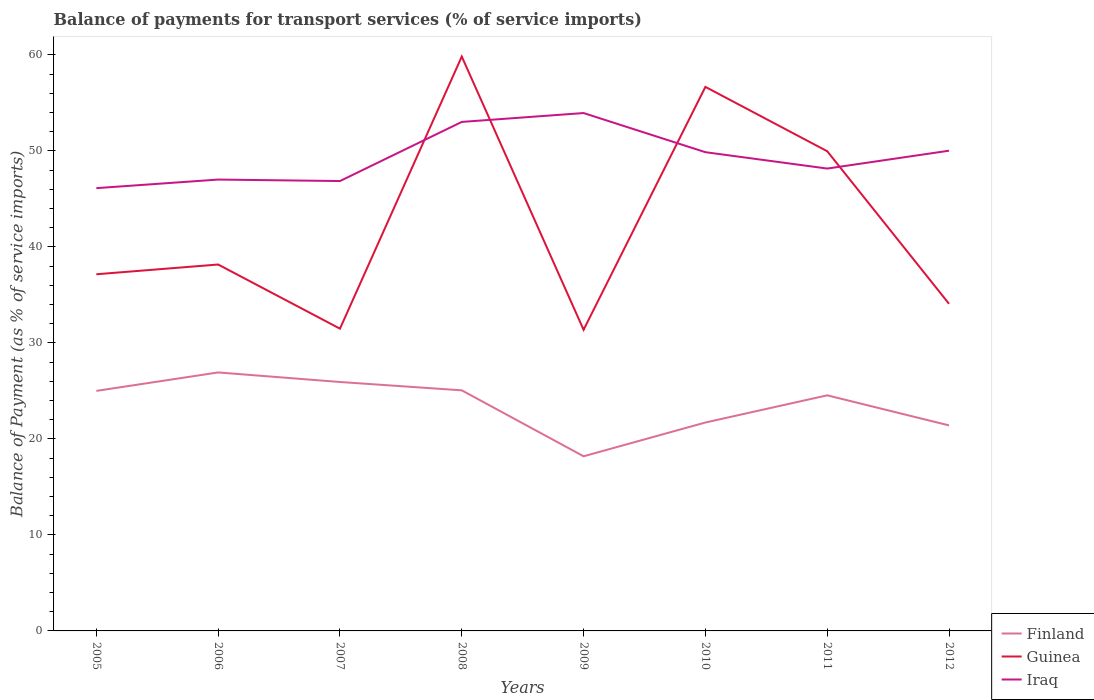How many different coloured lines are there?
Give a very brief answer. 3. Across all years, what is the maximum balance of payments for transport services in Iraq?
Keep it short and to the point. 46.13. In which year was the balance of payments for transport services in Iraq maximum?
Provide a short and direct response. 2005. What is the total balance of payments for transport services in Iraq in the graph?
Provide a succinct answer. -7.08. What is the difference between the highest and the second highest balance of payments for transport services in Finland?
Keep it short and to the point. 8.73. What is the difference between the highest and the lowest balance of payments for transport services in Guinea?
Ensure brevity in your answer.  3. How many lines are there?
Your answer should be compact. 3. Are the values on the major ticks of Y-axis written in scientific E-notation?
Give a very brief answer. No. Does the graph contain any zero values?
Your answer should be very brief. No. Does the graph contain grids?
Your answer should be compact. No. Where does the legend appear in the graph?
Offer a terse response. Bottom right. What is the title of the graph?
Your answer should be compact. Balance of payments for transport services (% of service imports). What is the label or title of the Y-axis?
Provide a succinct answer. Balance of Payment (as % of service imports). What is the Balance of Payment (as % of service imports) in Finland in 2005?
Keep it short and to the point. 25. What is the Balance of Payment (as % of service imports) of Guinea in 2005?
Your answer should be compact. 37.16. What is the Balance of Payment (as % of service imports) of Iraq in 2005?
Keep it short and to the point. 46.13. What is the Balance of Payment (as % of service imports) of Finland in 2006?
Provide a short and direct response. 26.93. What is the Balance of Payment (as % of service imports) of Guinea in 2006?
Provide a succinct answer. 38.17. What is the Balance of Payment (as % of service imports) in Iraq in 2006?
Offer a very short reply. 47.02. What is the Balance of Payment (as % of service imports) of Finland in 2007?
Offer a very short reply. 25.93. What is the Balance of Payment (as % of service imports) of Guinea in 2007?
Make the answer very short. 31.49. What is the Balance of Payment (as % of service imports) of Iraq in 2007?
Provide a short and direct response. 46.87. What is the Balance of Payment (as % of service imports) in Finland in 2008?
Offer a very short reply. 25.06. What is the Balance of Payment (as % of service imports) of Guinea in 2008?
Offer a terse response. 59.83. What is the Balance of Payment (as % of service imports) in Iraq in 2008?
Your response must be concise. 53.03. What is the Balance of Payment (as % of service imports) in Finland in 2009?
Give a very brief answer. 18.19. What is the Balance of Payment (as % of service imports) of Guinea in 2009?
Your answer should be compact. 31.37. What is the Balance of Payment (as % of service imports) of Iraq in 2009?
Your response must be concise. 53.95. What is the Balance of Payment (as % of service imports) of Finland in 2010?
Provide a short and direct response. 21.71. What is the Balance of Payment (as % of service imports) of Guinea in 2010?
Offer a very short reply. 56.67. What is the Balance of Payment (as % of service imports) in Iraq in 2010?
Your response must be concise. 49.87. What is the Balance of Payment (as % of service imports) of Finland in 2011?
Give a very brief answer. 24.54. What is the Balance of Payment (as % of service imports) of Guinea in 2011?
Give a very brief answer. 49.97. What is the Balance of Payment (as % of service imports) of Iraq in 2011?
Your response must be concise. 48.17. What is the Balance of Payment (as % of service imports) of Finland in 2012?
Provide a short and direct response. 21.41. What is the Balance of Payment (as % of service imports) in Guinea in 2012?
Offer a terse response. 34.08. What is the Balance of Payment (as % of service imports) of Iraq in 2012?
Your response must be concise. 50.03. Across all years, what is the maximum Balance of Payment (as % of service imports) in Finland?
Give a very brief answer. 26.93. Across all years, what is the maximum Balance of Payment (as % of service imports) in Guinea?
Your answer should be very brief. 59.83. Across all years, what is the maximum Balance of Payment (as % of service imports) of Iraq?
Provide a short and direct response. 53.95. Across all years, what is the minimum Balance of Payment (as % of service imports) in Finland?
Offer a terse response. 18.19. Across all years, what is the minimum Balance of Payment (as % of service imports) of Guinea?
Provide a succinct answer. 31.37. Across all years, what is the minimum Balance of Payment (as % of service imports) of Iraq?
Your answer should be compact. 46.13. What is the total Balance of Payment (as % of service imports) in Finland in the graph?
Your answer should be very brief. 188.79. What is the total Balance of Payment (as % of service imports) in Guinea in the graph?
Keep it short and to the point. 338.74. What is the total Balance of Payment (as % of service imports) in Iraq in the graph?
Make the answer very short. 395.05. What is the difference between the Balance of Payment (as % of service imports) in Finland in 2005 and that in 2006?
Offer a terse response. -1.92. What is the difference between the Balance of Payment (as % of service imports) of Guinea in 2005 and that in 2006?
Make the answer very short. -1.01. What is the difference between the Balance of Payment (as % of service imports) of Iraq in 2005 and that in 2006?
Give a very brief answer. -0.89. What is the difference between the Balance of Payment (as % of service imports) in Finland in 2005 and that in 2007?
Ensure brevity in your answer.  -0.93. What is the difference between the Balance of Payment (as % of service imports) in Guinea in 2005 and that in 2007?
Keep it short and to the point. 5.67. What is the difference between the Balance of Payment (as % of service imports) of Iraq in 2005 and that in 2007?
Provide a succinct answer. -0.74. What is the difference between the Balance of Payment (as % of service imports) of Finland in 2005 and that in 2008?
Offer a very short reply. -0.06. What is the difference between the Balance of Payment (as % of service imports) in Guinea in 2005 and that in 2008?
Provide a short and direct response. -22.68. What is the difference between the Balance of Payment (as % of service imports) in Iraq in 2005 and that in 2008?
Provide a succinct answer. -6.9. What is the difference between the Balance of Payment (as % of service imports) in Finland in 2005 and that in 2009?
Offer a very short reply. 6.81. What is the difference between the Balance of Payment (as % of service imports) in Guinea in 2005 and that in 2009?
Your answer should be very brief. 5.78. What is the difference between the Balance of Payment (as % of service imports) in Iraq in 2005 and that in 2009?
Offer a very short reply. -7.82. What is the difference between the Balance of Payment (as % of service imports) of Finland in 2005 and that in 2010?
Provide a succinct answer. 3.29. What is the difference between the Balance of Payment (as % of service imports) in Guinea in 2005 and that in 2010?
Give a very brief answer. -19.52. What is the difference between the Balance of Payment (as % of service imports) in Iraq in 2005 and that in 2010?
Keep it short and to the point. -3.74. What is the difference between the Balance of Payment (as % of service imports) in Finland in 2005 and that in 2011?
Your answer should be compact. 0.46. What is the difference between the Balance of Payment (as % of service imports) of Guinea in 2005 and that in 2011?
Make the answer very short. -12.82. What is the difference between the Balance of Payment (as % of service imports) of Iraq in 2005 and that in 2011?
Offer a very short reply. -2.04. What is the difference between the Balance of Payment (as % of service imports) of Finland in 2005 and that in 2012?
Your response must be concise. 3.59. What is the difference between the Balance of Payment (as % of service imports) of Guinea in 2005 and that in 2012?
Give a very brief answer. 3.08. What is the difference between the Balance of Payment (as % of service imports) in Iraq in 2005 and that in 2012?
Your answer should be very brief. -3.9. What is the difference between the Balance of Payment (as % of service imports) in Guinea in 2006 and that in 2007?
Your response must be concise. 6.68. What is the difference between the Balance of Payment (as % of service imports) in Iraq in 2006 and that in 2007?
Give a very brief answer. 0.15. What is the difference between the Balance of Payment (as % of service imports) of Finland in 2006 and that in 2008?
Keep it short and to the point. 1.86. What is the difference between the Balance of Payment (as % of service imports) in Guinea in 2006 and that in 2008?
Offer a very short reply. -21.66. What is the difference between the Balance of Payment (as % of service imports) of Iraq in 2006 and that in 2008?
Make the answer very short. -6.01. What is the difference between the Balance of Payment (as % of service imports) in Finland in 2006 and that in 2009?
Keep it short and to the point. 8.73. What is the difference between the Balance of Payment (as % of service imports) of Guinea in 2006 and that in 2009?
Your answer should be very brief. 6.8. What is the difference between the Balance of Payment (as % of service imports) of Iraq in 2006 and that in 2009?
Your answer should be compact. -6.93. What is the difference between the Balance of Payment (as % of service imports) of Finland in 2006 and that in 2010?
Your answer should be compact. 5.22. What is the difference between the Balance of Payment (as % of service imports) in Guinea in 2006 and that in 2010?
Your answer should be very brief. -18.5. What is the difference between the Balance of Payment (as % of service imports) in Iraq in 2006 and that in 2010?
Make the answer very short. -2.85. What is the difference between the Balance of Payment (as % of service imports) of Finland in 2006 and that in 2011?
Provide a succinct answer. 2.38. What is the difference between the Balance of Payment (as % of service imports) in Guinea in 2006 and that in 2011?
Your response must be concise. -11.8. What is the difference between the Balance of Payment (as % of service imports) in Iraq in 2006 and that in 2011?
Offer a very short reply. -1.15. What is the difference between the Balance of Payment (as % of service imports) of Finland in 2006 and that in 2012?
Offer a terse response. 5.52. What is the difference between the Balance of Payment (as % of service imports) in Guinea in 2006 and that in 2012?
Make the answer very short. 4.09. What is the difference between the Balance of Payment (as % of service imports) in Iraq in 2006 and that in 2012?
Provide a succinct answer. -3.01. What is the difference between the Balance of Payment (as % of service imports) of Finland in 2007 and that in 2008?
Your answer should be very brief. 0.87. What is the difference between the Balance of Payment (as % of service imports) in Guinea in 2007 and that in 2008?
Offer a terse response. -28.35. What is the difference between the Balance of Payment (as % of service imports) of Iraq in 2007 and that in 2008?
Your response must be concise. -6.16. What is the difference between the Balance of Payment (as % of service imports) of Finland in 2007 and that in 2009?
Ensure brevity in your answer.  7.74. What is the difference between the Balance of Payment (as % of service imports) in Guinea in 2007 and that in 2009?
Keep it short and to the point. 0.12. What is the difference between the Balance of Payment (as % of service imports) of Iraq in 2007 and that in 2009?
Keep it short and to the point. -7.08. What is the difference between the Balance of Payment (as % of service imports) of Finland in 2007 and that in 2010?
Keep it short and to the point. 4.22. What is the difference between the Balance of Payment (as % of service imports) in Guinea in 2007 and that in 2010?
Make the answer very short. -25.19. What is the difference between the Balance of Payment (as % of service imports) of Iraq in 2007 and that in 2010?
Provide a succinct answer. -3.01. What is the difference between the Balance of Payment (as % of service imports) in Finland in 2007 and that in 2011?
Offer a very short reply. 1.39. What is the difference between the Balance of Payment (as % of service imports) of Guinea in 2007 and that in 2011?
Ensure brevity in your answer.  -18.48. What is the difference between the Balance of Payment (as % of service imports) in Iraq in 2007 and that in 2011?
Your response must be concise. -1.3. What is the difference between the Balance of Payment (as % of service imports) in Finland in 2007 and that in 2012?
Your answer should be compact. 4.52. What is the difference between the Balance of Payment (as % of service imports) in Guinea in 2007 and that in 2012?
Your response must be concise. -2.59. What is the difference between the Balance of Payment (as % of service imports) in Iraq in 2007 and that in 2012?
Your response must be concise. -3.16. What is the difference between the Balance of Payment (as % of service imports) in Finland in 2008 and that in 2009?
Your answer should be very brief. 6.87. What is the difference between the Balance of Payment (as % of service imports) of Guinea in 2008 and that in 2009?
Your answer should be compact. 28.46. What is the difference between the Balance of Payment (as % of service imports) of Iraq in 2008 and that in 2009?
Your response must be concise. -0.92. What is the difference between the Balance of Payment (as % of service imports) in Finland in 2008 and that in 2010?
Give a very brief answer. 3.35. What is the difference between the Balance of Payment (as % of service imports) of Guinea in 2008 and that in 2010?
Provide a succinct answer. 3.16. What is the difference between the Balance of Payment (as % of service imports) of Iraq in 2008 and that in 2010?
Make the answer very short. 3.15. What is the difference between the Balance of Payment (as % of service imports) of Finland in 2008 and that in 2011?
Your answer should be compact. 0.52. What is the difference between the Balance of Payment (as % of service imports) in Guinea in 2008 and that in 2011?
Your answer should be very brief. 9.86. What is the difference between the Balance of Payment (as % of service imports) in Iraq in 2008 and that in 2011?
Your response must be concise. 4.86. What is the difference between the Balance of Payment (as % of service imports) of Finland in 2008 and that in 2012?
Offer a very short reply. 3.65. What is the difference between the Balance of Payment (as % of service imports) in Guinea in 2008 and that in 2012?
Make the answer very short. 25.76. What is the difference between the Balance of Payment (as % of service imports) of Iraq in 2008 and that in 2012?
Keep it short and to the point. 3. What is the difference between the Balance of Payment (as % of service imports) in Finland in 2009 and that in 2010?
Your response must be concise. -3.52. What is the difference between the Balance of Payment (as % of service imports) in Guinea in 2009 and that in 2010?
Your answer should be very brief. -25.3. What is the difference between the Balance of Payment (as % of service imports) in Iraq in 2009 and that in 2010?
Offer a very short reply. 4.08. What is the difference between the Balance of Payment (as % of service imports) of Finland in 2009 and that in 2011?
Your answer should be very brief. -6.35. What is the difference between the Balance of Payment (as % of service imports) of Guinea in 2009 and that in 2011?
Keep it short and to the point. -18.6. What is the difference between the Balance of Payment (as % of service imports) in Iraq in 2009 and that in 2011?
Provide a succinct answer. 5.78. What is the difference between the Balance of Payment (as % of service imports) of Finland in 2009 and that in 2012?
Your answer should be very brief. -3.22. What is the difference between the Balance of Payment (as % of service imports) in Guinea in 2009 and that in 2012?
Offer a terse response. -2.71. What is the difference between the Balance of Payment (as % of service imports) in Iraq in 2009 and that in 2012?
Your answer should be very brief. 3.92. What is the difference between the Balance of Payment (as % of service imports) of Finland in 2010 and that in 2011?
Ensure brevity in your answer.  -2.83. What is the difference between the Balance of Payment (as % of service imports) of Guinea in 2010 and that in 2011?
Offer a terse response. 6.7. What is the difference between the Balance of Payment (as % of service imports) in Iraq in 2010 and that in 2011?
Your response must be concise. 1.71. What is the difference between the Balance of Payment (as % of service imports) in Finland in 2010 and that in 2012?
Your answer should be compact. 0.3. What is the difference between the Balance of Payment (as % of service imports) of Guinea in 2010 and that in 2012?
Your answer should be very brief. 22.6. What is the difference between the Balance of Payment (as % of service imports) of Iraq in 2010 and that in 2012?
Provide a short and direct response. -0.15. What is the difference between the Balance of Payment (as % of service imports) in Finland in 2011 and that in 2012?
Offer a very short reply. 3.13. What is the difference between the Balance of Payment (as % of service imports) of Guinea in 2011 and that in 2012?
Ensure brevity in your answer.  15.89. What is the difference between the Balance of Payment (as % of service imports) of Iraq in 2011 and that in 2012?
Your answer should be compact. -1.86. What is the difference between the Balance of Payment (as % of service imports) of Finland in 2005 and the Balance of Payment (as % of service imports) of Guinea in 2006?
Give a very brief answer. -13.17. What is the difference between the Balance of Payment (as % of service imports) in Finland in 2005 and the Balance of Payment (as % of service imports) in Iraq in 2006?
Ensure brevity in your answer.  -22.02. What is the difference between the Balance of Payment (as % of service imports) of Guinea in 2005 and the Balance of Payment (as % of service imports) of Iraq in 2006?
Your answer should be very brief. -9.86. What is the difference between the Balance of Payment (as % of service imports) of Finland in 2005 and the Balance of Payment (as % of service imports) of Guinea in 2007?
Your response must be concise. -6.48. What is the difference between the Balance of Payment (as % of service imports) of Finland in 2005 and the Balance of Payment (as % of service imports) of Iraq in 2007?
Offer a very short reply. -21.86. What is the difference between the Balance of Payment (as % of service imports) in Guinea in 2005 and the Balance of Payment (as % of service imports) in Iraq in 2007?
Your answer should be compact. -9.71. What is the difference between the Balance of Payment (as % of service imports) of Finland in 2005 and the Balance of Payment (as % of service imports) of Guinea in 2008?
Provide a short and direct response. -34.83. What is the difference between the Balance of Payment (as % of service imports) of Finland in 2005 and the Balance of Payment (as % of service imports) of Iraq in 2008?
Make the answer very short. -28.02. What is the difference between the Balance of Payment (as % of service imports) in Guinea in 2005 and the Balance of Payment (as % of service imports) in Iraq in 2008?
Your response must be concise. -15.87. What is the difference between the Balance of Payment (as % of service imports) of Finland in 2005 and the Balance of Payment (as % of service imports) of Guinea in 2009?
Provide a succinct answer. -6.37. What is the difference between the Balance of Payment (as % of service imports) in Finland in 2005 and the Balance of Payment (as % of service imports) in Iraq in 2009?
Offer a very short reply. -28.94. What is the difference between the Balance of Payment (as % of service imports) in Guinea in 2005 and the Balance of Payment (as % of service imports) in Iraq in 2009?
Give a very brief answer. -16.79. What is the difference between the Balance of Payment (as % of service imports) of Finland in 2005 and the Balance of Payment (as % of service imports) of Guinea in 2010?
Provide a succinct answer. -31.67. What is the difference between the Balance of Payment (as % of service imports) of Finland in 2005 and the Balance of Payment (as % of service imports) of Iraq in 2010?
Give a very brief answer. -24.87. What is the difference between the Balance of Payment (as % of service imports) in Guinea in 2005 and the Balance of Payment (as % of service imports) in Iraq in 2010?
Your answer should be compact. -12.72. What is the difference between the Balance of Payment (as % of service imports) in Finland in 2005 and the Balance of Payment (as % of service imports) in Guinea in 2011?
Provide a short and direct response. -24.97. What is the difference between the Balance of Payment (as % of service imports) of Finland in 2005 and the Balance of Payment (as % of service imports) of Iraq in 2011?
Your answer should be very brief. -23.16. What is the difference between the Balance of Payment (as % of service imports) of Guinea in 2005 and the Balance of Payment (as % of service imports) of Iraq in 2011?
Give a very brief answer. -11.01. What is the difference between the Balance of Payment (as % of service imports) of Finland in 2005 and the Balance of Payment (as % of service imports) of Guinea in 2012?
Offer a very short reply. -9.07. What is the difference between the Balance of Payment (as % of service imports) in Finland in 2005 and the Balance of Payment (as % of service imports) in Iraq in 2012?
Make the answer very short. -25.02. What is the difference between the Balance of Payment (as % of service imports) in Guinea in 2005 and the Balance of Payment (as % of service imports) in Iraq in 2012?
Provide a succinct answer. -12.87. What is the difference between the Balance of Payment (as % of service imports) in Finland in 2006 and the Balance of Payment (as % of service imports) in Guinea in 2007?
Offer a very short reply. -4.56. What is the difference between the Balance of Payment (as % of service imports) in Finland in 2006 and the Balance of Payment (as % of service imports) in Iraq in 2007?
Offer a terse response. -19.94. What is the difference between the Balance of Payment (as % of service imports) of Guinea in 2006 and the Balance of Payment (as % of service imports) of Iraq in 2007?
Give a very brief answer. -8.7. What is the difference between the Balance of Payment (as % of service imports) of Finland in 2006 and the Balance of Payment (as % of service imports) of Guinea in 2008?
Your answer should be compact. -32.91. What is the difference between the Balance of Payment (as % of service imports) of Finland in 2006 and the Balance of Payment (as % of service imports) of Iraq in 2008?
Provide a short and direct response. -26.1. What is the difference between the Balance of Payment (as % of service imports) of Guinea in 2006 and the Balance of Payment (as % of service imports) of Iraq in 2008?
Offer a very short reply. -14.86. What is the difference between the Balance of Payment (as % of service imports) in Finland in 2006 and the Balance of Payment (as % of service imports) in Guinea in 2009?
Make the answer very short. -4.44. What is the difference between the Balance of Payment (as % of service imports) of Finland in 2006 and the Balance of Payment (as % of service imports) of Iraq in 2009?
Your answer should be compact. -27.02. What is the difference between the Balance of Payment (as % of service imports) of Guinea in 2006 and the Balance of Payment (as % of service imports) of Iraq in 2009?
Your response must be concise. -15.78. What is the difference between the Balance of Payment (as % of service imports) in Finland in 2006 and the Balance of Payment (as % of service imports) in Guinea in 2010?
Ensure brevity in your answer.  -29.75. What is the difference between the Balance of Payment (as % of service imports) in Finland in 2006 and the Balance of Payment (as % of service imports) in Iraq in 2010?
Offer a very short reply. -22.94. What is the difference between the Balance of Payment (as % of service imports) of Guinea in 2006 and the Balance of Payment (as % of service imports) of Iraq in 2010?
Make the answer very short. -11.7. What is the difference between the Balance of Payment (as % of service imports) of Finland in 2006 and the Balance of Payment (as % of service imports) of Guinea in 2011?
Make the answer very short. -23.04. What is the difference between the Balance of Payment (as % of service imports) of Finland in 2006 and the Balance of Payment (as % of service imports) of Iraq in 2011?
Provide a succinct answer. -21.24. What is the difference between the Balance of Payment (as % of service imports) of Guinea in 2006 and the Balance of Payment (as % of service imports) of Iraq in 2011?
Your answer should be very brief. -10. What is the difference between the Balance of Payment (as % of service imports) of Finland in 2006 and the Balance of Payment (as % of service imports) of Guinea in 2012?
Give a very brief answer. -7.15. What is the difference between the Balance of Payment (as % of service imports) in Finland in 2006 and the Balance of Payment (as % of service imports) in Iraq in 2012?
Ensure brevity in your answer.  -23.1. What is the difference between the Balance of Payment (as % of service imports) of Guinea in 2006 and the Balance of Payment (as % of service imports) of Iraq in 2012?
Your answer should be compact. -11.86. What is the difference between the Balance of Payment (as % of service imports) in Finland in 2007 and the Balance of Payment (as % of service imports) in Guinea in 2008?
Your answer should be very brief. -33.9. What is the difference between the Balance of Payment (as % of service imports) in Finland in 2007 and the Balance of Payment (as % of service imports) in Iraq in 2008?
Keep it short and to the point. -27.09. What is the difference between the Balance of Payment (as % of service imports) in Guinea in 2007 and the Balance of Payment (as % of service imports) in Iraq in 2008?
Offer a very short reply. -21.54. What is the difference between the Balance of Payment (as % of service imports) of Finland in 2007 and the Balance of Payment (as % of service imports) of Guinea in 2009?
Keep it short and to the point. -5.44. What is the difference between the Balance of Payment (as % of service imports) in Finland in 2007 and the Balance of Payment (as % of service imports) in Iraq in 2009?
Ensure brevity in your answer.  -28.02. What is the difference between the Balance of Payment (as % of service imports) in Guinea in 2007 and the Balance of Payment (as % of service imports) in Iraq in 2009?
Make the answer very short. -22.46. What is the difference between the Balance of Payment (as % of service imports) of Finland in 2007 and the Balance of Payment (as % of service imports) of Guinea in 2010?
Ensure brevity in your answer.  -30.74. What is the difference between the Balance of Payment (as % of service imports) in Finland in 2007 and the Balance of Payment (as % of service imports) in Iraq in 2010?
Your response must be concise. -23.94. What is the difference between the Balance of Payment (as % of service imports) in Guinea in 2007 and the Balance of Payment (as % of service imports) in Iraq in 2010?
Make the answer very short. -18.38. What is the difference between the Balance of Payment (as % of service imports) in Finland in 2007 and the Balance of Payment (as % of service imports) in Guinea in 2011?
Ensure brevity in your answer.  -24.04. What is the difference between the Balance of Payment (as % of service imports) of Finland in 2007 and the Balance of Payment (as % of service imports) of Iraq in 2011?
Provide a short and direct response. -22.23. What is the difference between the Balance of Payment (as % of service imports) of Guinea in 2007 and the Balance of Payment (as % of service imports) of Iraq in 2011?
Provide a short and direct response. -16.68. What is the difference between the Balance of Payment (as % of service imports) in Finland in 2007 and the Balance of Payment (as % of service imports) in Guinea in 2012?
Provide a short and direct response. -8.15. What is the difference between the Balance of Payment (as % of service imports) in Finland in 2007 and the Balance of Payment (as % of service imports) in Iraq in 2012?
Your answer should be very brief. -24.09. What is the difference between the Balance of Payment (as % of service imports) in Guinea in 2007 and the Balance of Payment (as % of service imports) in Iraq in 2012?
Your answer should be compact. -18.54. What is the difference between the Balance of Payment (as % of service imports) of Finland in 2008 and the Balance of Payment (as % of service imports) of Guinea in 2009?
Your answer should be compact. -6.31. What is the difference between the Balance of Payment (as % of service imports) of Finland in 2008 and the Balance of Payment (as % of service imports) of Iraq in 2009?
Keep it short and to the point. -28.89. What is the difference between the Balance of Payment (as % of service imports) of Guinea in 2008 and the Balance of Payment (as % of service imports) of Iraq in 2009?
Keep it short and to the point. 5.88. What is the difference between the Balance of Payment (as % of service imports) of Finland in 2008 and the Balance of Payment (as % of service imports) of Guinea in 2010?
Offer a terse response. -31.61. What is the difference between the Balance of Payment (as % of service imports) of Finland in 2008 and the Balance of Payment (as % of service imports) of Iraq in 2010?
Offer a very short reply. -24.81. What is the difference between the Balance of Payment (as % of service imports) in Guinea in 2008 and the Balance of Payment (as % of service imports) in Iraq in 2010?
Your response must be concise. 9.96. What is the difference between the Balance of Payment (as % of service imports) of Finland in 2008 and the Balance of Payment (as % of service imports) of Guinea in 2011?
Keep it short and to the point. -24.91. What is the difference between the Balance of Payment (as % of service imports) of Finland in 2008 and the Balance of Payment (as % of service imports) of Iraq in 2011?
Offer a very short reply. -23.1. What is the difference between the Balance of Payment (as % of service imports) in Guinea in 2008 and the Balance of Payment (as % of service imports) in Iraq in 2011?
Provide a succinct answer. 11.67. What is the difference between the Balance of Payment (as % of service imports) of Finland in 2008 and the Balance of Payment (as % of service imports) of Guinea in 2012?
Your response must be concise. -9.01. What is the difference between the Balance of Payment (as % of service imports) of Finland in 2008 and the Balance of Payment (as % of service imports) of Iraq in 2012?
Your answer should be very brief. -24.96. What is the difference between the Balance of Payment (as % of service imports) in Guinea in 2008 and the Balance of Payment (as % of service imports) in Iraq in 2012?
Your answer should be very brief. 9.81. What is the difference between the Balance of Payment (as % of service imports) of Finland in 2009 and the Balance of Payment (as % of service imports) of Guinea in 2010?
Your response must be concise. -38.48. What is the difference between the Balance of Payment (as % of service imports) in Finland in 2009 and the Balance of Payment (as % of service imports) in Iraq in 2010?
Your response must be concise. -31.68. What is the difference between the Balance of Payment (as % of service imports) of Guinea in 2009 and the Balance of Payment (as % of service imports) of Iraq in 2010?
Make the answer very short. -18.5. What is the difference between the Balance of Payment (as % of service imports) of Finland in 2009 and the Balance of Payment (as % of service imports) of Guinea in 2011?
Your answer should be very brief. -31.78. What is the difference between the Balance of Payment (as % of service imports) of Finland in 2009 and the Balance of Payment (as % of service imports) of Iraq in 2011?
Offer a terse response. -29.97. What is the difference between the Balance of Payment (as % of service imports) of Guinea in 2009 and the Balance of Payment (as % of service imports) of Iraq in 2011?
Provide a succinct answer. -16.79. What is the difference between the Balance of Payment (as % of service imports) of Finland in 2009 and the Balance of Payment (as % of service imports) of Guinea in 2012?
Keep it short and to the point. -15.88. What is the difference between the Balance of Payment (as % of service imports) of Finland in 2009 and the Balance of Payment (as % of service imports) of Iraq in 2012?
Your answer should be very brief. -31.83. What is the difference between the Balance of Payment (as % of service imports) in Guinea in 2009 and the Balance of Payment (as % of service imports) in Iraq in 2012?
Offer a very short reply. -18.65. What is the difference between the Balance of Payment (as % of service imports) of Finland in 2010 and the Balance of Payment (as % of service imports) of Guinea in 2011?
Ensure brevity in your answer.  -28.26. What is the difference between the Balance of Payment (as % of service imports) of Finland in 2010 and the Balance of Payment (as % of service imports) of Iraq in 2011?
Make the answer very short. -26.46. What is the difference between the Balance of Payment (as % of service imports) of Guinea in 2010 and the Balance of Payment (as % of service imports) of Iraq in 2011?
Provide a short and direct response. 8.51. What is the difference between the Balance of Payment (as % of service imports) of Finland in 2010 and the Balance of Payment (as % of service imports) of Guinea in 2012?
Keep it short and to the point. -12.37. What is the difference between the Balance of Payment (as % of service imports) of Finland in 2010 and the Balance of Payment (as % of service imports) of Iraq in 2012?
Provide a succinct answer. -28.32. What is the difference between the Balance of Payment (as % of service imports) of Guinea in 2010 and the Balance of Payment (as % of service imports) of Iraq in 2012?
Your answer should be compact. 6.65. What is the difference between the Balance of Payment (as % of service imports) of Finland in 2011 and the Balance of Payment (as % of service imports) of Guinea in 2012?
Provide a succinct answer. -9.53. What is the difference between the Balance of Payment (as % of service imports) of Finland in 2011 and the Balance of Payment (as % of service imports) of Iraq in 2012?
Make the answer very short. -25.48. What is the difference between the Balance of Payment (as % of service imports) of Guinea in 2011 and the Balance of Payment (as % of service imports) of Iraq in 2012?
Your answer should be compact. -0.05. What is the average Balance of Payment (as % of service imports) in Finland per year?
Keep it short and to the point. 23.6. What is the average Balance of Payment (as % of service imports) of Guinea per year?
Provide a short and direct response. 42.34. What is the average Balance of Payment (as % of service imports) in Iraq per year?
Your response must be concise. 49.38. In the year 2005, what is the difference between the Balance of Payment (as % of service imports) in Finland and Balance of Payment (as % of service imports) in Guinea?
Your response must be concise. -12.15. In the year 2005, what is the difference between the Balance of Payment (as % of service imports) in Finland and Balance of Payment (as % of service imports) in Iraq?
Offer a terse response. -21.12. In the year 2005, what is the difference between the Balance of Payment (as % of service imports) in Guinea and Balance of Payment (as % of service imports) in Iraq?
Offer a terse response. -8.97. In the year 2006, what is the difference between the Balance of Payment (as % of service imports) in Finland and Balance of Payment (as % of service imports) in Guinea?
Offer a very short reply. -11.24. In the year 2006, what is the difference between the Balance of Payment (as % of service imports) of Finland and Balance of Payment (as % of service imports) of Iraq?
Offer a terse response. -20.09. In the year 2006, what is the difference between the Balance of Payment (as % of service imports) of Guinea and Balance of Payment (as % of service imports) of Iraq?
Provide a short and direct response. -8.85. In the year 2007, what is the difference between the Balance of Payment (as % of service imports) in Finland and Balance of Payment (as % of service imports) in Guinea?
Offer a very short reply. -5.56. In the year 2007, what is the difference between the Balance of Payment (as % of service imports) of Finland and Balance of Payment (as % of service imports) of Iraq?
Your response must be concise. -20.93. In the year 2007, what is the difference between the Balance of Payment (as % of service imports) of Guinea and Balance of Payment (as % of service imports) of Iraq?
Ensure brevity in your answer.  -15.38. In the year 2008, what is the difference between the Balance of Payment (as % of service imports) in Finland and Balance of Payment (as % of service imports) in Guinea?
Make the answer very short. -34.77. In the year 2008, what is the difference between the Balance of Payment (as % of service imports) in Finland and Balance of Payment (as % of service imports) in Iraq?
Keep it short and to the point. -27.96. In the year 2008, what is the difference between the Balance of Payment (as % of service imports) in Guinea and Balance of Payment (as % of service imports) in Iraq?
Ensure brevity in your answer.  6.81. In the year 2009, what is the difference between the Balance of Payment (as % of service imports) in Finland and Balance of Payment (as % of service imports) in Guinea?
Provide a succinct answer. -13.18. In the year 2009, what is the difference between the Balance of Payment (as % of service imports) in Finland and Balance of Payment (as % of service imports) in Iraq?
Your response must be concise. -35.76. In the year 2009, what is the difference between the Balance of Payment (as % of service imports) in Guinea and Balance of Payment (as % of service imports) in Iraq?
Give a very brief answer. -22.58. In the year 2010, what is the difference between the Balance of Payment (as % of service imports) of Finland and Balance of Payment (as % of service imports) of Guinea?
Give a very brief answer. -34.96. In the year 2010, what is the difference between the Balance of Payment (as % of service imports) in Finland and Balance of Payment (as % of service imports) in Iraq?
Keep it short and to the point. -28.16. In the year 2010, what is the difference between the Balance of Payment (as % of service imports) of Guinea and Balance of Payment (as % of service imports) of Iraq?
Give a very brief answer. 6.8. In the year 2011, what is the difference between the Balance of Payment (as % of service imports) in Finland and Balance of Payment (as % of service imports) in Guinea?
Offer a terse response. -25.43. In the year 2011, what is the difference between the Balance of Payment (as % of service imports) of Finland and Balance of Payment (as % of service imports) of Iraq?
Your response must be concise. -23.62. In the year 2011, what is the difference between the Balance of Payment (as % of service imports) in Guinea and Balance of Payment (as % of service imports) in Iraq?
Your response must be concise. 1.81. In the year 2012, what is the difference between the Balance of Payment (as % of service imports) of Finland and Balance of Payment (as % of service imports) of Guinea?
Ensure brevity in your answer.  -12.67. In the year 2012, what is the difference between the Balance of Payment (as % of service imports) in Finland and Balance of Payment (as % of service imports) in Iraq?
Keep it short and to the point. -28.62. In the year 2012, what is the difference between the Balance of Payment (as % of service imports) in Guinea and Balance of Payment (as % of service imports) in Iraq?
Ensure brevity in your answer.  -15.95. What is the ratio of the Balance of Payment (as % of service imports) in Finland in 2005 to that in 2006?
Your answer should be very brief. 0.93. What is the ratio of the Balance of Payment (as % of service imports) of Guinea in 2005 to that in 2006?
Your response must be concise. 0.97. What is the ratio of the Balance of Payment (as % of service imports) of Iraq in 2005 to that in 2006?
Your answer should be very brief. 0.98. What is the ratio of the Balance of Payment (as % of service imports) of Finland in 2005 to that in 2007?
Your answer should be compact. 0.96. What is the ratio of the Balance of Payment (as % of service imports) of Guinea in 2005 to that in 2007?
Offer a terse response. 1.18. What is the ratio of the Balance of Payment (as % of service imports) in Iraq in 2005 to that in 2007?
Provide a short and direct response. 0.98. What is the ratio of the Balance of Payment (as % of service imports) of Finland in 2005 to that in 2008?
Your response must be concise. 1. What is the ratio of the Balance of Payment (as % of service imports) in Guinea in 2005 to that in 2008?
Your answer should be compact. 0.62. What is the ratio of the Balance of Payment (as % of service imports) of Iraq in 2005 to that in 2008?
Make the answer very short. 0.87. What is the ratio of the Balance of Payment (as % of service imports) in Finland in 2005 to that in 2009?
Offer a very short reply. 1.37. What is the ratio of the Balance of Payment (as % of service imports) of Guinea in 2005 to that in 2009?
Your answer should be very brief. 1.18. What is the ratio of the Balance of Payment (as % of service imports) of Iraq in 2005 to that in 2009?
Your answer should be very brief. 0.85. What is the ratio of the Balance of Payment (as % of service imports) in Finland in 2005 to that in 2010?
Your response must be concise. 1.15. What is the ratio of the Balance of Payment (as % of service imports) of Guinea in 2005 to that in 2010?
Your answer should be very brief. 0.66. What is the ratio of the Balance of Payment (as % of service imports) of Iraq in 2005 to that in 2010?
Offer a very short reply. 0.92. What is the ratio of the Balance of Payment (as % of service imports) in Finland in 2005 to that in 2011?
Offer a very short reply. 1.02. What is the ratio of the Balance of Payment (as % of service imports) of Guinea in 2005 to that in 2011?
Offer a terse response. 0.74. What is the ratio of the Balance of Payment (as % of service imports) of Iraq in 2005 to that in 2011?
Your answer should be very brief. 0.96. What is the ratio of the Balance of Payment (as % of service imports) of Finland in 2005 to that in 2012?
Offer a terse response. 1.17. What is the ratio of the Balance of Payment (as % of service imports) in Guinea in 2005 to that in 2012?
Make the answer very short. 1.09. What is the ratio of the Balance of Payment (as % of service imports) in Iraq in 2005 to that in 2012?
Provide a short and direct response. 0.92. What is the ratio of the Balance of Payment (as % of service imports) in Finland in 2006 to that in 2007?
Give a very brief answer. 1.04. What is the ratio of the Balance of Payment (as % of service imports) in Guinea in 2006 to that in 2007?
Make the answer very short. 1.21. What is the ratio of the Balance of Payment (as % of service imports) in Iraq in 2006 to that in 2007?
Your answer should be compact. 1. What is the ratio of the Balance of Payment (as % of service imports) in Finland in 2006 to that in 2008?
Provide a short and direct response. 1.07. What is the ratio of the Balance of Payment (as % of service imports) of Guinea in 2006 to that in 2008?
Provide a short and direct response. 0.64. What is the ratio of the Balance of Payment (as % of service imports) in Iraq in 2006 to that in 2008?
Provide a short and direct response. 0.89. What is the ratio of the Balance of Payment (as % of service imports) in Finland in 2006 to that in 2009?
Offer a terse response. 1.48. What is the ratio of the Balance of Payment (as % of service imports) in Guinea in 2006 to that in 2009?
Your answer should be very brief. 1.22. What is the ratio of the Balance of Payment (as % of service imports) of Iraq in 2006 to that in 2009?
Ensure brevity in your answer.  0.87. What is the ratio of the Balance of Payment (as % of service imports) in Finland in 2006 to that in 2010?
Keep it short and to the point. 1.24. What is the ratio of the Balance of Payment (as % of service imports) in Guinea in 2006 to that in 2010?
Your answer should be very brief. 0.67. What is the ratio of the Balance of Payment (as % of service imports) in Iraq in 2006 to that in 2010?
Give a very brief answer. 0.94. What is the ratio of the Balance of Payment (as % of service imports) of Finland in 2006 to that in 2011?
Make the answer very short. 1.1. What is the ratio of the Balance of Payment (as % of service imports) in Guinea in 2006 to that in 2011?
Provide a short and direct response. 0.76. What is the ratio of the Balance of Payment (as % of service imports) of Iraq in 2006 to that in 2011?
Provide a succinct answer. 0.98. What is the ratio of the Balance of Payment (as % of service imports) of Finland in 2006 to that in 2012?
Provide a short and direct response. 1.26. What is the ratio of the Balance of Payment (as % of service imports) in Guinea in 2006 to that in 2012?
Give a very brief answer. 1.12. What is the ratio of the Balance of Payment (as % of service imports) of Iraq in 2006 to that in 2012?
Make the answer very short. 0.94. What is the ratio of the Balance of Payment (as % of service imports) of Finland in 2007 to that in 2008?
Provide a succinct answer. 1.03. What is the ratio of the Balance of Payment (as % of service imports) of Guinea in 2007 to that in 2008?
Offer a very short reply. 0.53. What is the ratio of the Balance of Payment (as % of service imports) of Iraq in 2007 to that in 2008?
Provide a short and direct response. 0.88. What is the ratio of the Balance of Payment (as % of service imports) of Finland in 2007 to that in 2009?
Offer a very short reply. 1.43. What is the ratio of the Balance of Payment (as % of service imports) in Guinea in 2007 to that in 2009?
Your answer should be compact. 1. What is the ratio of the Balance of Payment (as % of service imports) in Iraq in 2007 to that in 2009?
Your answer should be compact. 0.87. What is the ratio of the Balance of Payment (as % of service imports) in Finland in 2007 to that in 2010?
Your response must be concise. 1.19. What is the ratio of the Balance of Payment (as % of service imports) of Guinea in 2007 to that in 2010?
Give a very brief answer. 0.56. What is the ratio of the Balance of Payment (as % of service imports) in Iraq in 2007 to that in 2010?
Keep it short and to the point. 0.94. What is the ratio of the Balance of Payment (as % of service imports) of Finland in 2007 to that in 2011?
Provide a short and direct response. 1.06. What is the ratio of the Balance of Payment (as % of service imports) of Guinea in 2007 to that in 2011?
Your answer should be compact. 0.63. What is the ratio of the Balance of Payment (as % of service imports) in Iraq in 2007 to that in 2011?
Provide a short and direct response. 0.97. What is the ratio of the Balance of Payment (as % of service imports) of Finland in 2007 to that in 2012?
Give a very brief answer. 1.21. What is the ratio of the Balance of Payment (as % of service imports) in Guinea in 2007 to that in 2012?
Your answer should be very brief. 0.92. What is the ratio of the Balance of Payment (as % of service imports) in Iraq in 2007 to that in 2012?
Your answer should be compact. 0.94. What is the ratio of the Balance of Payment (as % of service imports) in Finland in 2008 to that in 2009?
Provide a short and direct response. 1.38. What is the ratio of the Balance of Payment (as % of service imports) of Guinea in 2008 to that in 2009?
Make the answer very short. 1.91. What is the ratio of the Balance of Payment (as % of service imports) of Iraq in 2008 to that in 2009?
Your response must be concise. 0.98. What is the ratio of the Balance of Payment (as % of service imports) in Finland in 2008 to that in 2010?
Ensure brevity in your answer.  1.15. What is the ratio of the Balance of Payment (as % of service imports) of Guinea in 2008 to that in 2010?
Provide a short and direct response. 1.06. What is the ratio of the Balance of Payment (as % of service imports) in Iraq in 2008 to that in 2010?
Ensure brevity in your answer.  1.06. What is the ratio of the Balance of Payment (as % of service imports) in Finland in 2008 to that in 2011?
Provide a short and direct response. 1.02. What is the ratio of the Balance of Payment (as % of service imports) in Guinea in 2008 to that in 2011?
Your answer should be compact. 1.2. What is the ratio of the Balance of Payment (as % of service imports) of Iraq in 2008 to that in 2011?
Offer a very short reply. 1.1. What is the ratio of the Balance of Payment (as % of service imports) of Finland in 2008 to that in 2012?
Offer a very short reply. 1.17. What is the ratio of the Balance of Payment (as % of service imports) of Guinea in 2008 to that in 2012?
Keep it short and to the point. 1.76. What is the ratio of the Balance of Payment (as % of service imports) of Iraq in 2008 to that in 2012?
Offer a terse response. 1.06. What is the ratio of the Balance of Payment (as % of service imports) in Finland in 2009 to that in 2010?
Keep it short and to the point. 0.84. What is the ratio of the Balance of Payment (as % of service imports) in Guinea in 2009 to that in 2010?
Offer a very short reply. 0.55. What is the ratio of the Balance of Payment (as % of service imports) of Iraq in 2009 to that in 2010?
Your answer should be very brief. 1.08. What is the ratio of the Balance of Payment (as % of service imports) of Finland in 2009 to that in 2011?
Make the answer very short. 0.74. What is the ratio of the Balance of Payment (as % of service imports) of Guinea in 2009 to that in 2011?
Your response must be concise. 0.63. What is the ratio of the Balance of Payment (as % of service imports) in Iraq in 2009 to that in 2011?
Your response must be concise. 1.12. What is the ratio of the Balance of Payment (as % of service imports) in Finland in 2009 to that in 2012?
Provide a short and direct response. 0.85. What is the ratio of the Balance of Payment (as % of service imports) of Guinea in 2009 to that in 2012?
Offer a terse response. 0.92. What is the ratio of the Balance of Payment (as % of service imports) of Iraq in 2009 to that in 2012?
Keep it short and to the point. 1.08. What is the ratio of the Balance of Payment (as % of service imports) in Finland in 2010 to that in 2011?
Provide a succinct answer. 0.88. What is the ratio of the Balance of Payment (as % of service imports) in Guinea in 2010 to that in 2011?
Provide a short and direct response. 1.13. What is the ratio of the Balance of Payment (as % of service imports) in Iraq in 2010 to that in 2011?
Give a very brief answer. 1.04. What is the ratio of the Balance of Payment (as % of service imports) of Guinea in 2010 to that in 2012?
Provide a succinct answer. 1.66. What is the ratio of the Balance of Payment (as % of service imports) of Iraq in 2010 to that in 2012?
Make the answer very short. 1. What is the ratio of the Balance of Payment (as % of service imports) of Finland in 2011 to that in 2012?
Ensure brevity in your answer.  1.15. What is the ratio of the Balance of Payment (as % of service imports) in Guinea in 2011 to that in 2012?
Make the answer very short. 1.47. What is the ratio of the Balance of Payment (as % of service imports) in Iraq in 2011 to that in 2012?
Provide a short and direct response. 0.96. What is the difference between the highest and the second highest Balance of Payment (as % of service imports) of Finland?
Offer a terse response. 1. What is the difference between the highest and the second highest Balance of Payment (as % of service imports) of Guinea?
Make the answer very short. 3.16. What is the difference between the highest and the second highest Balance of Payment (as % of service imports) in Iraq?
Make the answer very short. 0.92. What is the difference between the highest and the lowest Balance of Payment (as % of service imports) of Finland?
Ensure brevity in your answer.  8.73. What is the difference between the highest and the lowest Balance of Payment (as % of service imports) in Guinea?
Offer a terse response. 28.46. What is the difference between the highest and the lowest Balance of Payment (as % of service imports) in Iraq?
Ensure brevity in your answer.  7.82. 